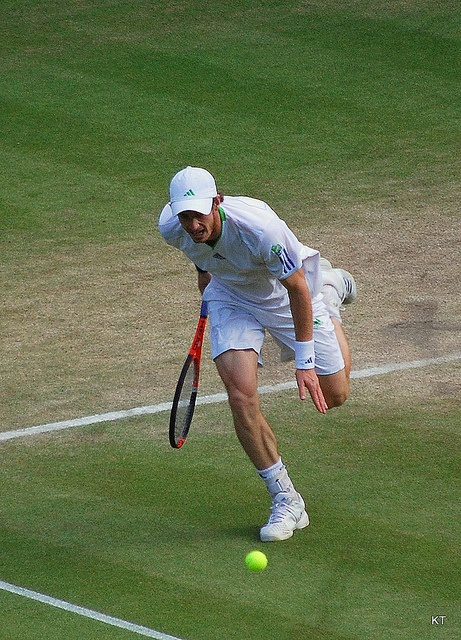Describe the objects in this image and their specific colors. I can see people in darkgreen, lightgray, gray, and darkgray tones, tennis racket in darkgreen, gray, black, and darkgray tones, and sports ball in darkgreen, yellow, green, lime, and lightgreen tones in this image. 